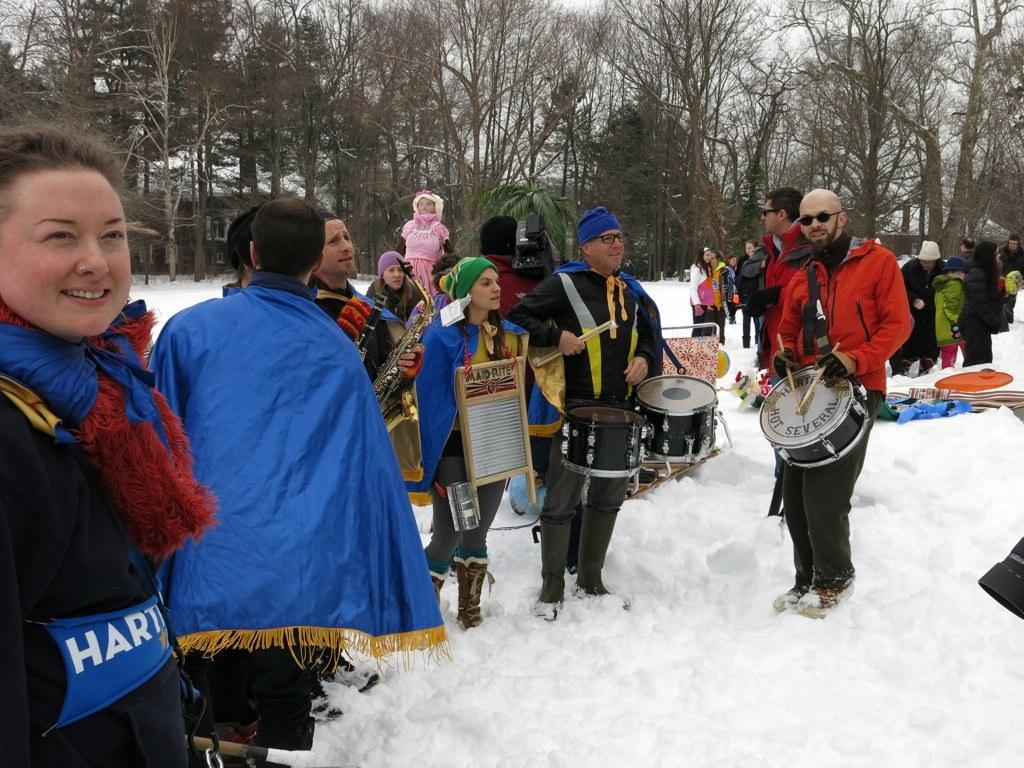<image>
Provide a brief description of the given image. A man is holding a snare drum that has the word several on it. 